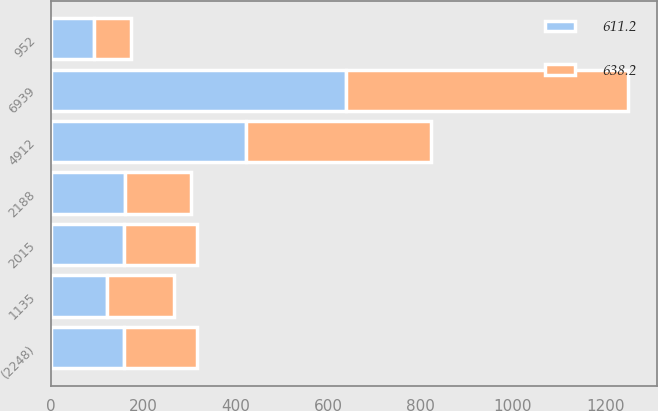Convert chart. <chart><loc_0><loc_0><loc_500><loc_500><stacked_bar_chart><ecel><fcel>2015<fcel>4912<fcel>1135<fcel>2188<fcel>952<fcel>(2248)<fcel>6939<nl><fcel>611.2<fcel>157.6<fcel>421<fcel>121<fcel>160.7<fcel>93.4<fcel>157.9<fcel>638.2<nl><fcel>638.2<fcel>157.6<fcel>401.3<fcel>145.3<fcel>142.6<fcel>79.3<fcel>157.3<fcel>611.2<nl></chart> 